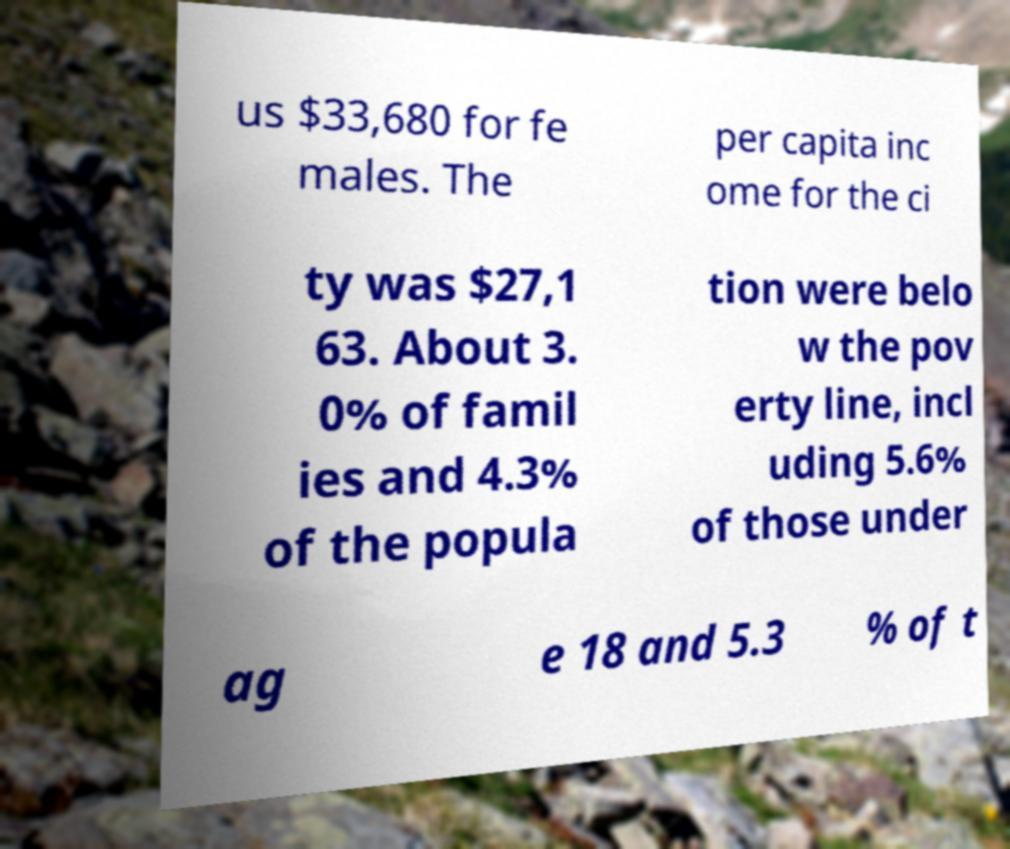What messages or text are displayed in this image? I need them in a readable, typed format. us $33,680 for fe males. The per capita inc ome for the ci ty was $27,1 63. About 3. 0% of famil ies and 4.3% of the popula tion were belo w the pov erty line, incl uding 5.6% of those under ag e 18 and 5.3 % of t 